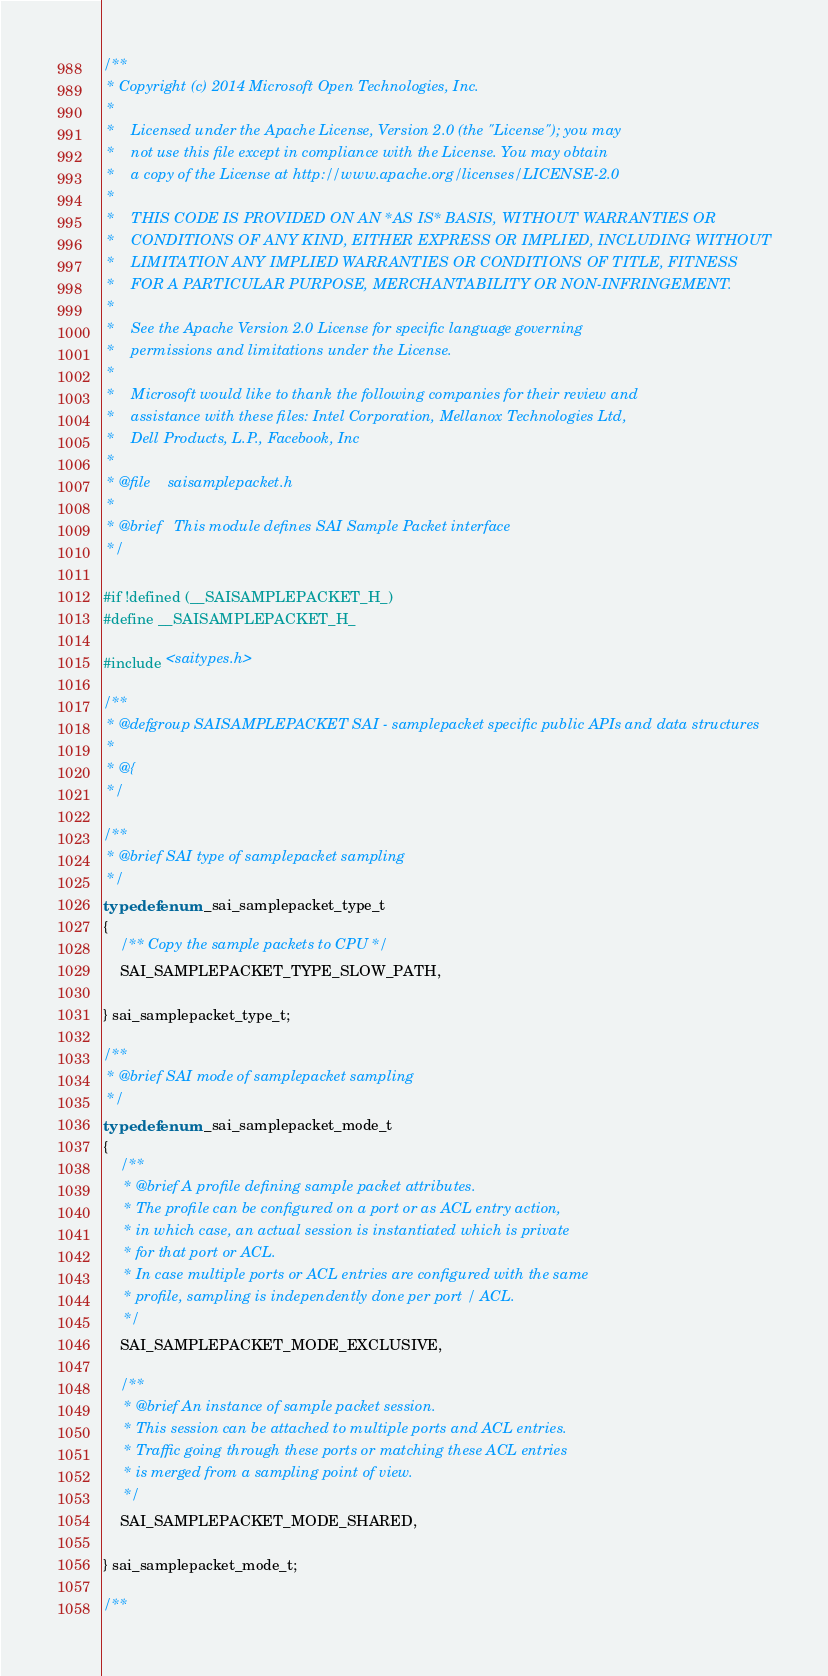<code> <loc_0><loc_0><loc_500><loc_500><_C_>/**
 * Copyright (c) 2014 Microsoft Open Technologies, Inc.
 *
 *    Licensed under the Apache License, Version 2.0 (the "License"); you may
 *    not use this file except in compliance with the License. You may obtain
 *    a copy of the License at http://www.apache.org/licenses/LICENSE-2.0
 *
 *    THIS CODE IS PROVIDED ON AN *AS IS* BASIS, WITHOUT WARRANTIES OR
 *    CONDITIONS OF ANY KIND, EITHER EXPRESS OR IMPLIED, INCLUDING WITHOUT
 *    LIMITATION ANY IMPLIED WARRANTIES OR CONDITIONS OF TITLE, FITNESS
 *    FOR A PARTICULAR PURPOSE, MERCHANTABILITY OR NON-INFRINGEMENT.
 *
 *    See the Apache Version 2.0 License for specific language governing
 *    permissions and limitations under the License.
 *
 *    Microsoft would like to thank the following companies for their review and
 *    assistance with these files: Intel Corporation, Mellanox Technologies Ltd,
 *    Dell Products, L.P., Facebook, Inc
 *
 * @file    saisamplepacket.h
 *
 * @brief   This module defines SAI Sample Packet interface
 */

#if !defined (__SAISAMPLEPACKET_H_)
#define __SAISAMPLEPACKET_H_

#include <saitypes.h>

/**
 * @defgroup SAISAMPLEPACKET SAI - samplepacket specific public APIs and data structures
 *
 * @{
 */

/**
 * @brief SAI type of samplepacket sampling
 */
typedef enum _sai_samplepacket_type_t
{
    /** Copy the sample packets to CPU */
    SAI_SAMPLEPACKET_TYPE_SLOW_PATH,

} sai_samplepacket_type_t;

/**
 * @brief SAI mode of samplepacket sampling
 */
typedef enum _sai_samplepacket_mode_t
{
    /**
     * @brief A profile defining sample packet attributes.
     * The profile can be configured on a port or as ACL entry action,
     * in which case, an actual session is instantiated which is private
     * for that port or ACL.
     * In case multiple ports or ACL entries are configured with the same
     * profile, sampling is independently done per port / ACL.
     */
    SAI_SAMPLEPACKET_MODE_EXCLUSIVE,

    /**
     * @brief An instance of sample packet session.
     * This session can be attached to multiple ports and ACL entries.
     * Traffic going through these ports or matching these ACL entries
     * is merged from a sampling point of view.
     */
    SAI_SAMPLEPACKET_MODE_SHARED,

} sai_samplepacket_mode_t;

/**</code> 